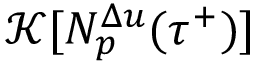Convert formula to latex. <formula><loc_0><loc_0><loc_500><loc_500>\mathcal { K } [ N _ { p } ^ { \Delta u } ( { \tau } ^ { + } ) ]</formula> 